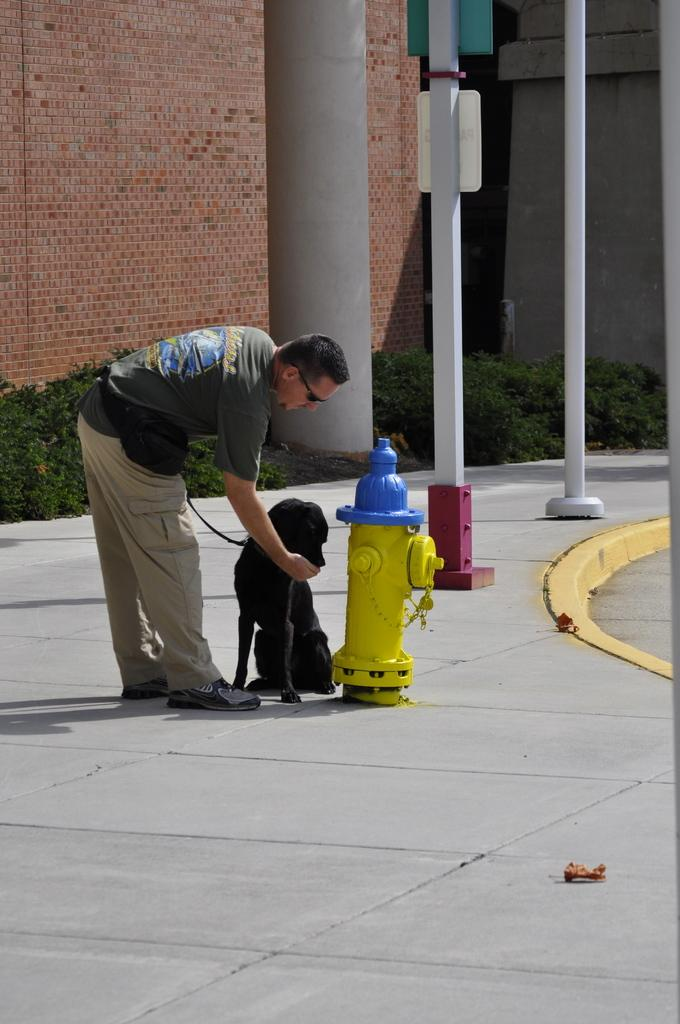What object can be seen in the image that is used for fire safety? There is a fire hydrant in the image. Who is present in the image? There is a man and a dog in the image. What can be seen in the background of the image? There are poles, a pillar, and buildings in the background of the image. What is present on the ground in the image? Plants and other objects are present on the ground in the image. Can you tell me how many bananas are on the ground in the image? There are no bananas present in the image. What type of car can be seen driving past the fire hydrant in the image? There is no car present in the image. 